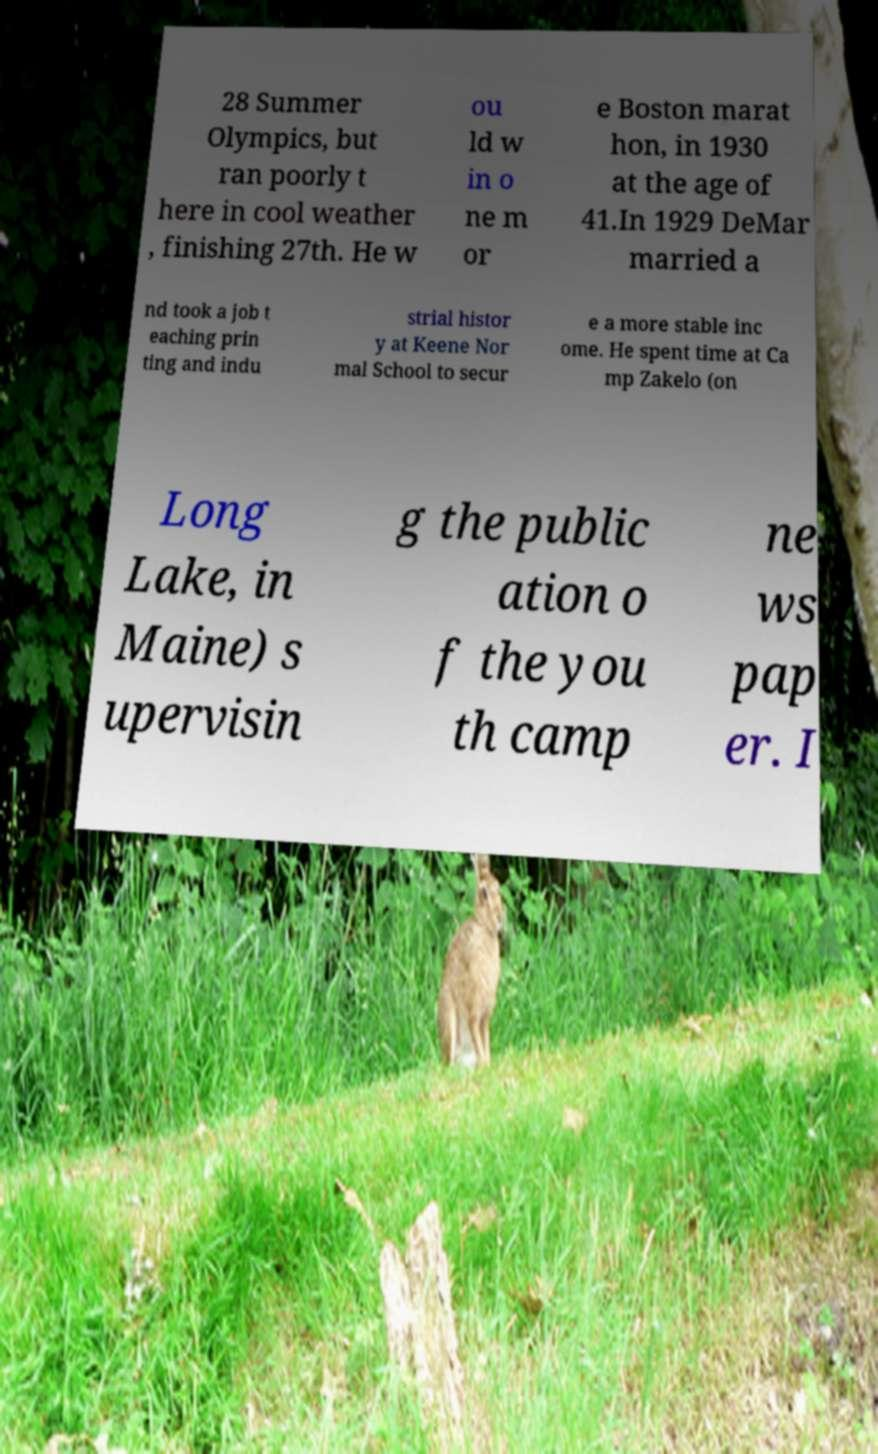Can you accurately transcribe the text from the provided image for me? 28 Summer Olympics, but ran poorly t here in cool weather , finishing 27th. He w ou ld w in o ne m or e Boston marat hon, in 1930 at the age of 41.In 1929 DeMar married a nd took a job t eaching prin ting and indu strial histor y at Keene Nor mal School to secur e a more stable inc ome. He spent time at Ca mp Zakelo (on Long Lake, in Maine) s upervisin g the public ation o f the you th camp ne ws pap er. I 